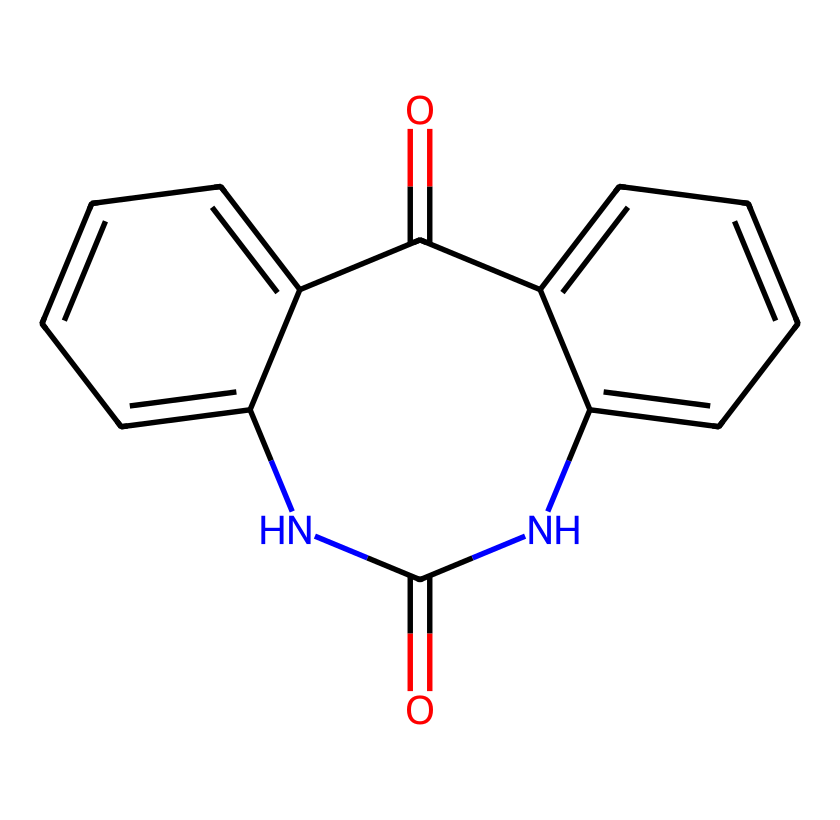What is the molecular formula of this compound? To derive the molecular formula, count the number of each type of atom in the SMILES representation. The structure contains 15 carbon atoms, 10 hydrogen atoms, 4 nitrogen atoms, and 2 oxygen atoms. Thus, the formula is C15H10N4O2.
Answer: C15H10N4O2 How many nitrogen atoms are present in the structure? The SMILES representation indicates two nitrogen (N) atoms through the segments where N appears. Counting gives us 4 nitrogen atoms total in the structure.
Answer: 4 What does the presence of the nitrogen atoms suggest about the chemical's properties? The presence of nitrogen atoms suggests that this molecule could exhibit basic properties as nitrogen is common in basic compounds and can accept protons.
Answer: basic How many rings are present in this molecule? By analyzing the structure from the SMILES, two rings can be identified due to the notation of numbers which indicate the closure of ring structures.
Answer: 2 What role do the carbonyl groups (C=O) play in the chemical's structure? The carbonyl groups in the molecule often contribute to resonance stabilization and can influence the electronic and optical properties, enhancing color vibrancy in pigments.
Answer: resonance Is this compound considered a base or an acid? Given the presence of nitrogen that can donate a lone pair for protonation, this compound is considered a base. Additionally, it does not display characteristics of a typical acid (which would typically exhibit proton donor properties).
Answer: base 